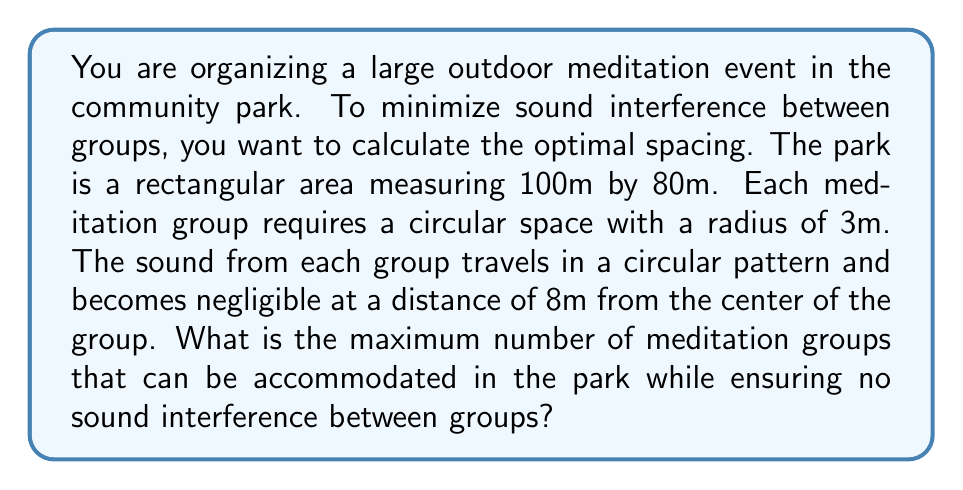Teach me how to tackle this problem. To solve this problem, we need to follow these steps:

1. Calculate the minimum distance between the centers of two adjacent meditation groups:
   The minimum distance should be twice the radius of sound travel.
   $d_{min} = 2 \times 8m = 16m$

2. Determine the number of groups that can fit along the length and width of the park:
   For the length (100m): $n_l = \lfloor \frac{100m}{16m} \rfloor = 6$
   For the width (80m): $n_w = \lfloor \frac{80m}{16m} \rfloor = 5$

3. Calculate the total number of groups:
   $N_{total} = n_l \times n_w = 6 \times 5 = 30$

4. Verify if there's enough space at the edges:
   Remaining space along length: $100m - (6 \times 16m) = 4m$
   Remaining space along width: $80m - (5 \times 16m) = 0m$
   
   The remaining space is less than the diameter of a meditation group (6m), so we can't add more groups.

5. Check if the corner spaces can accommodate additional groups:
   Diagonal distance between corner groups:
   $d_{diagonal} = \sqrt{16^2 + 16^2} = 16\sqrt{2} \approx 22.63m > 16m$
   
   This means we can't add groups in the corners without causing interference.

Therefore, the maximum number of meditation groups that can be accommodated while ensuring no sound interference is 30.

[asy]
size(300,240);
for(int i=0; i<6; ++i)
  for(int j=0; j<5; ++j) {
    draw(circle((i*16,j*16),8), blue);
    fill(circle((i*16,j*16),3), red);
  }
draw(box((0,0),(100,80)), black+1);
label("100m", (50,-5), S);
label("80m", (-5,40), W);
[/asy]
Answer: The maximum number of meditation groups that can be accommodated in the park while ensuring no sound interference is 30. 